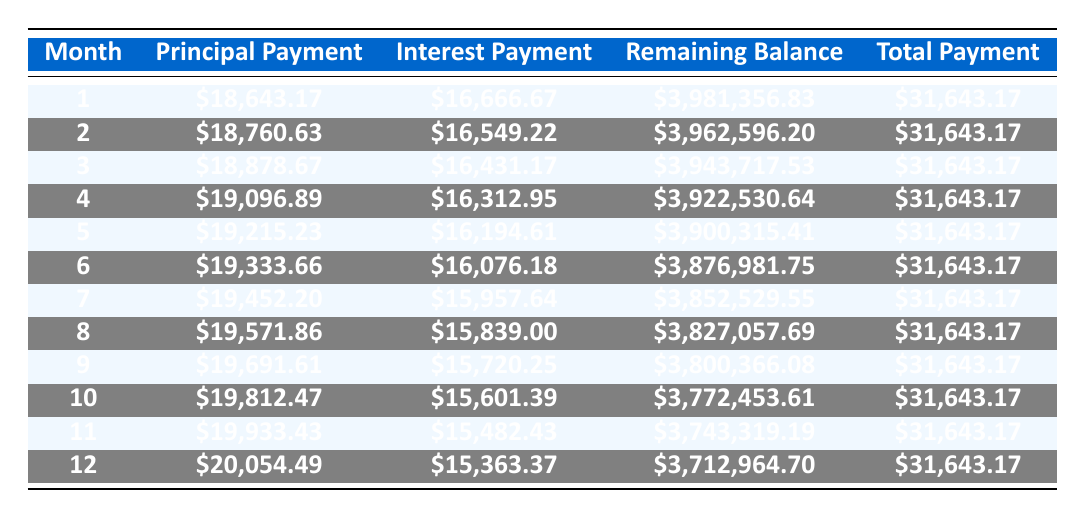What is the total monthly payment for the loan? The total monthly payment is listed in the table under the “Total Payment” column for each month. It consistently shows as \$31,643.17 for all the months.
Answer: 31643.17 What is the principal payment for the first month? The principal payment for the first month is found in the “Principal Payment” column of the first row, which shows \$18,643.17.
Answer: 18643.17 Does the interest payment decrease over time? By examining the “Interest Payment” column, we can see that the values start at \$16,666.67 in the first month and decrease consistently for each subsequent month.
Answer: Yes What is the total interest paid after 12 months? To find the total interest paid, we can sum the “Interest Payment” values for the first 12 months. Adding those values results in a total of \$193,369.97.
Answer: 193369.97 What is the remaining balance after the 6th month? The remaining balance is found in the “Remaining Balance” column corresponding to the 6th month, which shows \$3,876,981.75.
Answer: 3876981.75 How much does the principal payment increase by the 12th month compared to the first month? The principal payment in the first month is \$18,643.17 and in the twelfth month it is \$20,054.49. The increase can be calculated as \$20,054.49 - \$18,643.17 = \$1,411.32.
Answer: 1411.32 Is the total payment for each month the same? The “Total Payment” column shows that every month maintains the same payment of \$31,643.17, confirming uniformity across payments.
Answer: Yes What is the average monthly principal payment over the first 12 months? We can sum the principal payments for the first 12 months and divide by 12. The total principal paid that month is \$232,401.65, resulting in an average of \$19,366.80.
Answer: 19366.80 What is the highest interest payment made in any of the first 12 months? By examining the “Interest Payment” column for the first 12 months, the highest value is listed in the first month, which is \$16,666.67.
Answer: 16666.67 